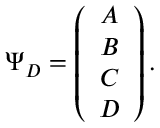Convert formula to latex. <formula><loc_0><loc_0><loc_500><loc_500>\Psi _ { D } = \left ( \begin{array} { c } { A } \\ { B } \\ { C } \\ { D } \end{array} \right ) .</formula> 